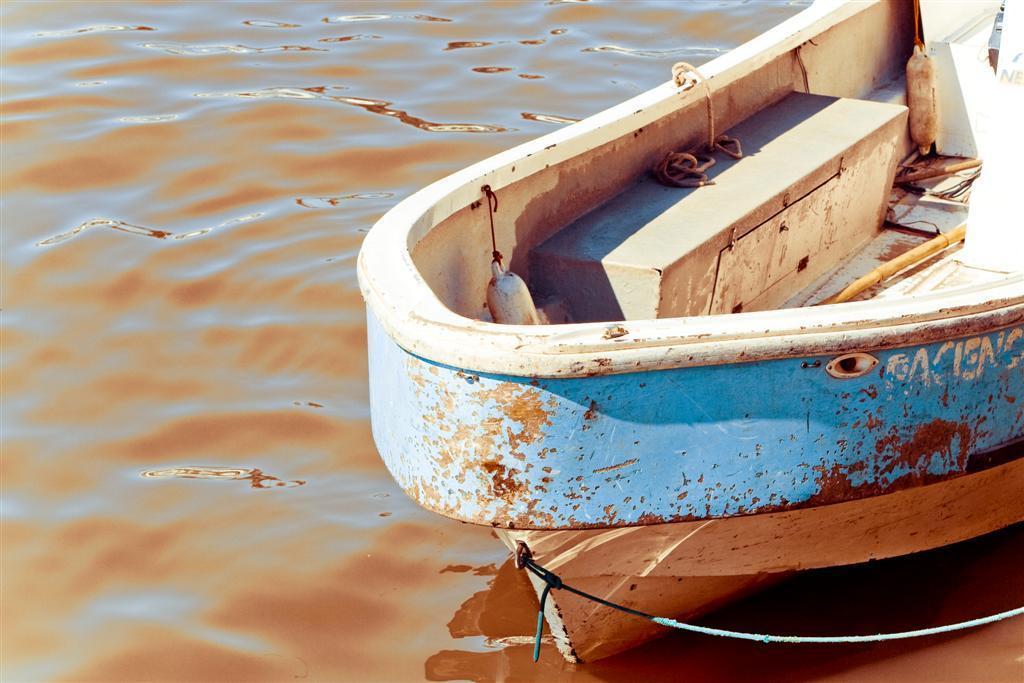Can you describe this image briefly? This image is taken outdoors. On the left side of the image there is a river with water. On the right side of the image there is a boat on the river. There are a few ropes and there is a stick. 